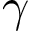Convert formula to latex. <formula><loc_0><loc_0><loc_500><loc_500>\gamma</formula> 